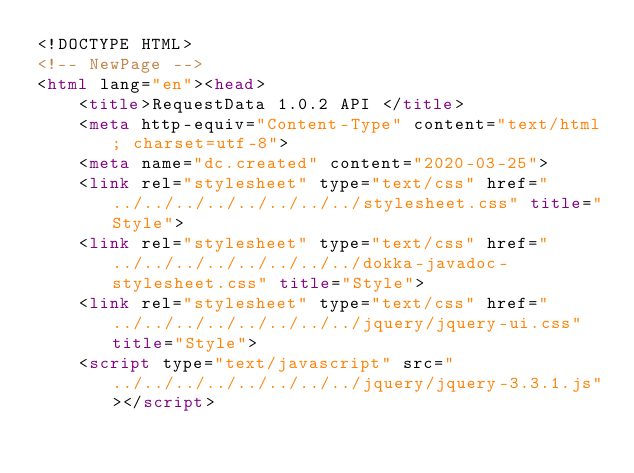Convert code to text. <code><loc_0><loc_0><loc_500><loc_500><_HTML_><!DOCTYPE HTML>
<!-- NewPage -->
<html lang="en"><head>
    <title>RequestData 1.0.2 API </title>
    <meta http-equiv="Content-Type" content="text/html; charset=utf-8">
    <meta name="dc.created" content="2020-03-25">
    <link rel="stylesheet" type="text/css" href="../../../../../../../../stylesheet.css" title="Style">
    <link rel="stylesheet" type="text/css" href="../../../../../../../../dokka-javadoc-stylesheet.css" title="Style">
    <link rel="stylesheet" type="text/css" href="../../../../../../../../jquery/jquery-ui.css" title="Style">
    <script type="text/javascript" src="../../../../../../../../jquery/jquery-3.3.1.js"></script></code> 